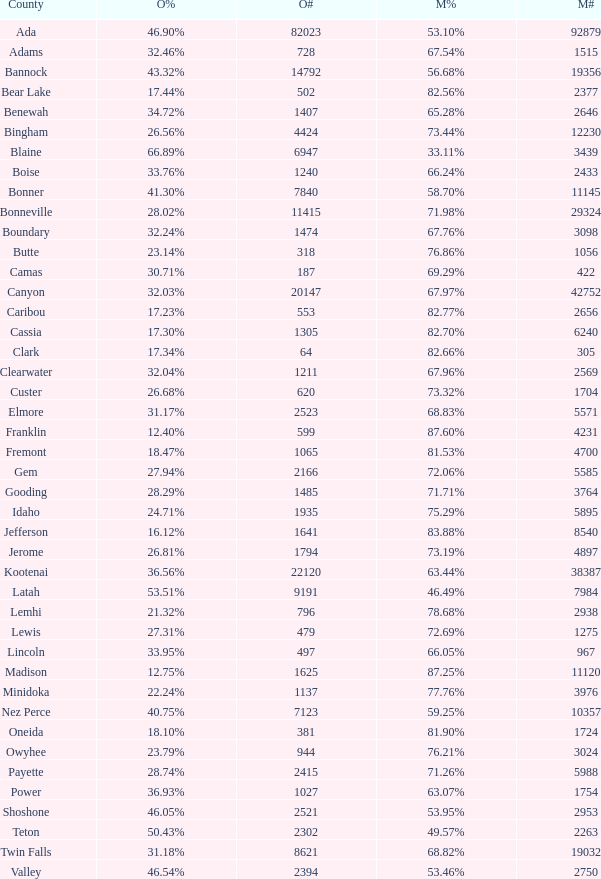What is the maximum McCain population turnout number? 92879.0. 